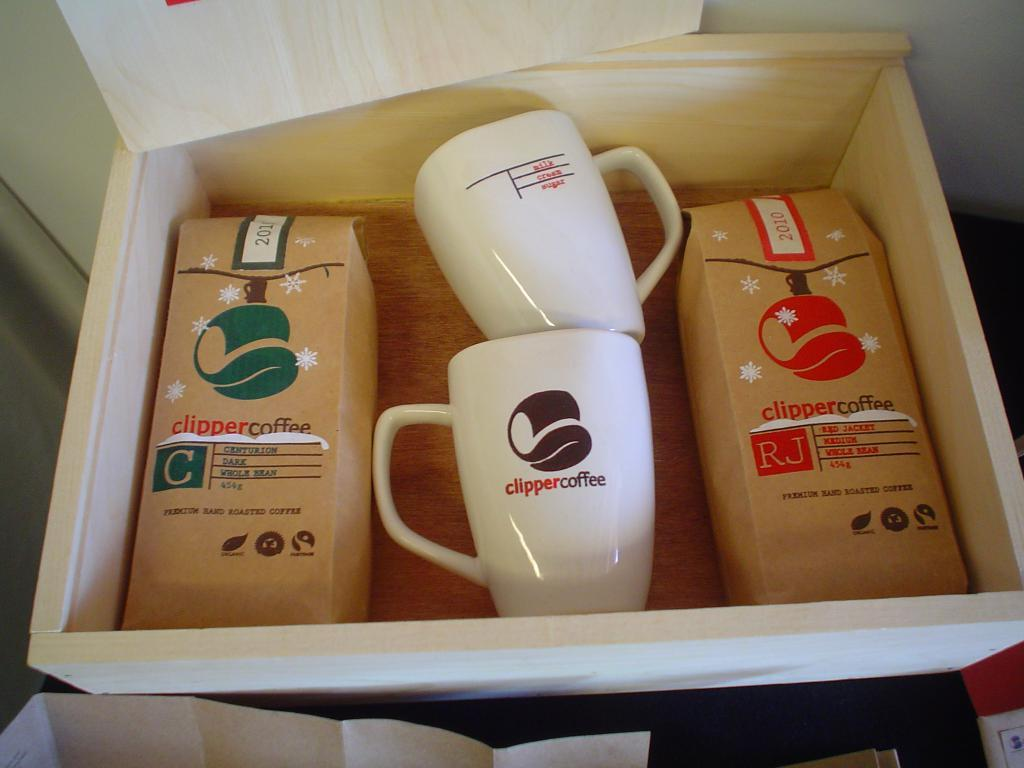<image>
Give a short and clear explanation of the subsequent image. the word clipper is on the coffee mug 